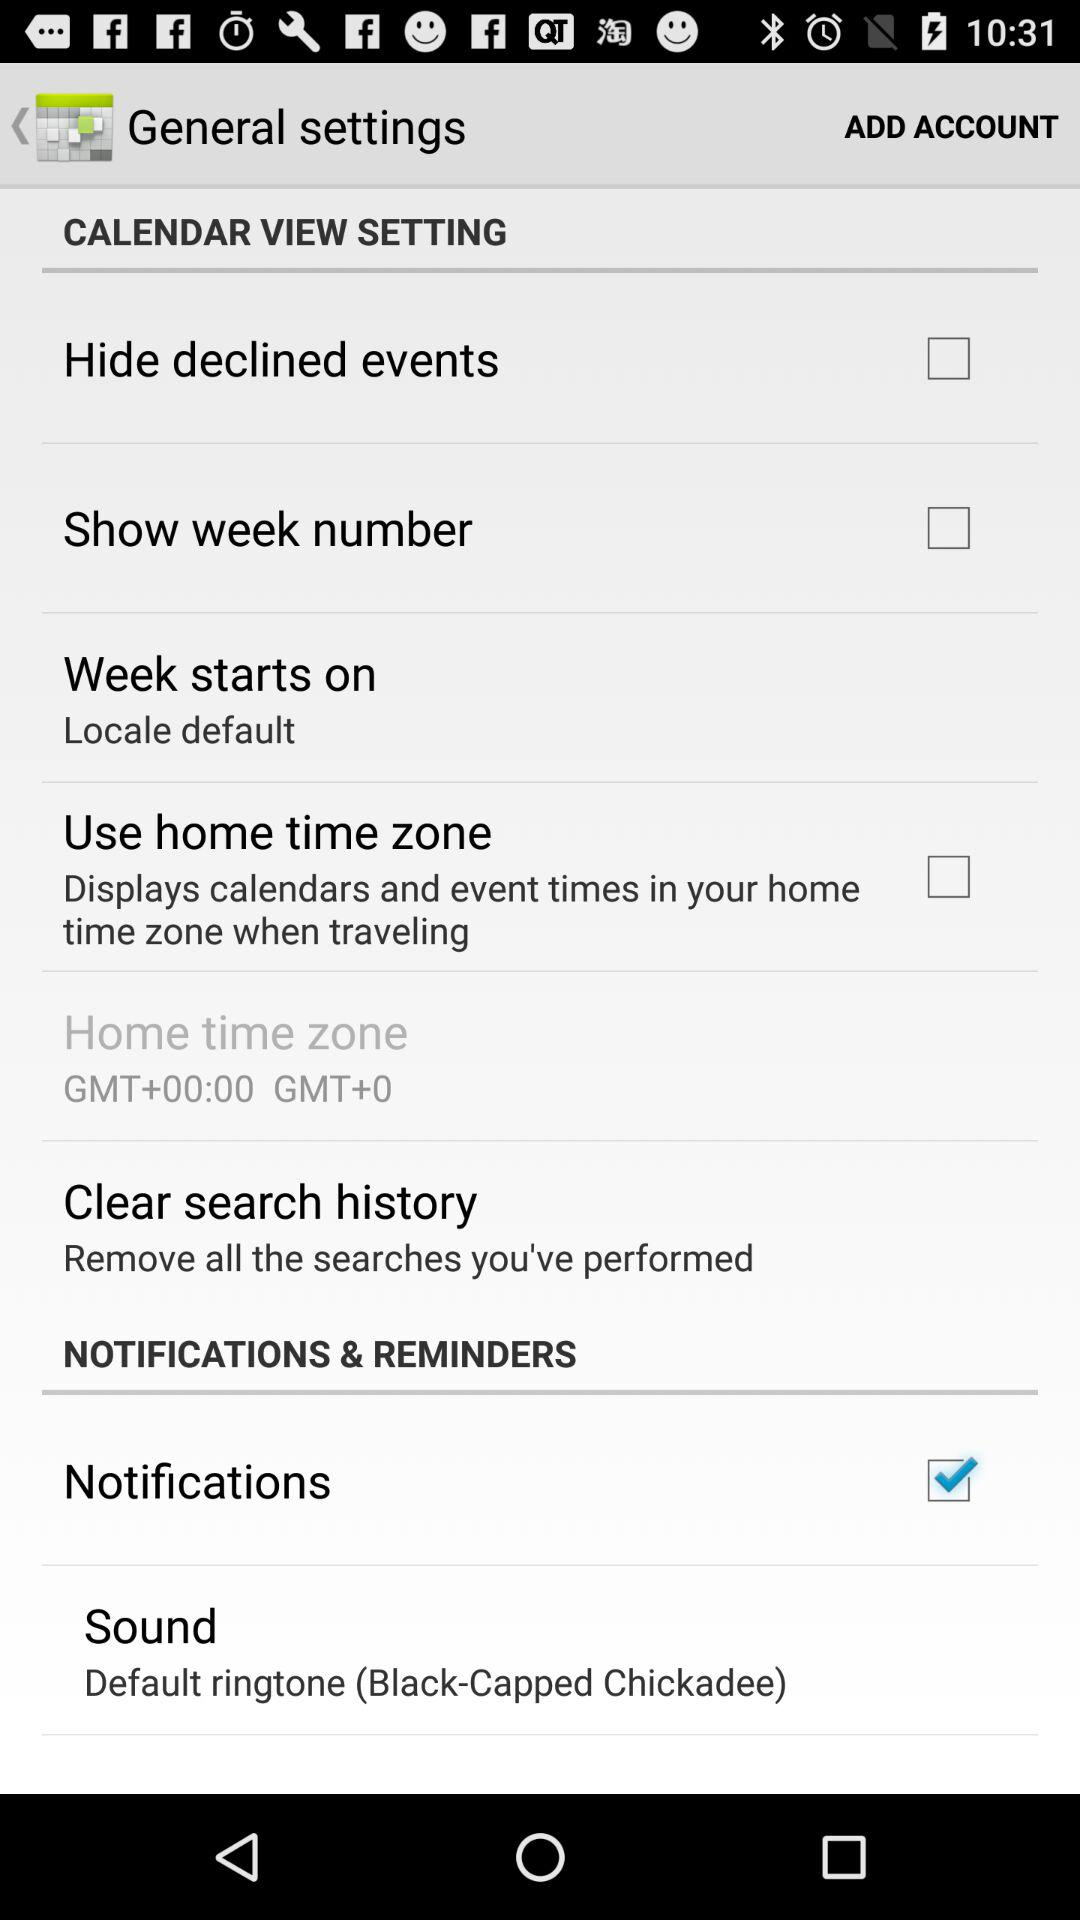Which option is checked? The checked option is "Notifications". 